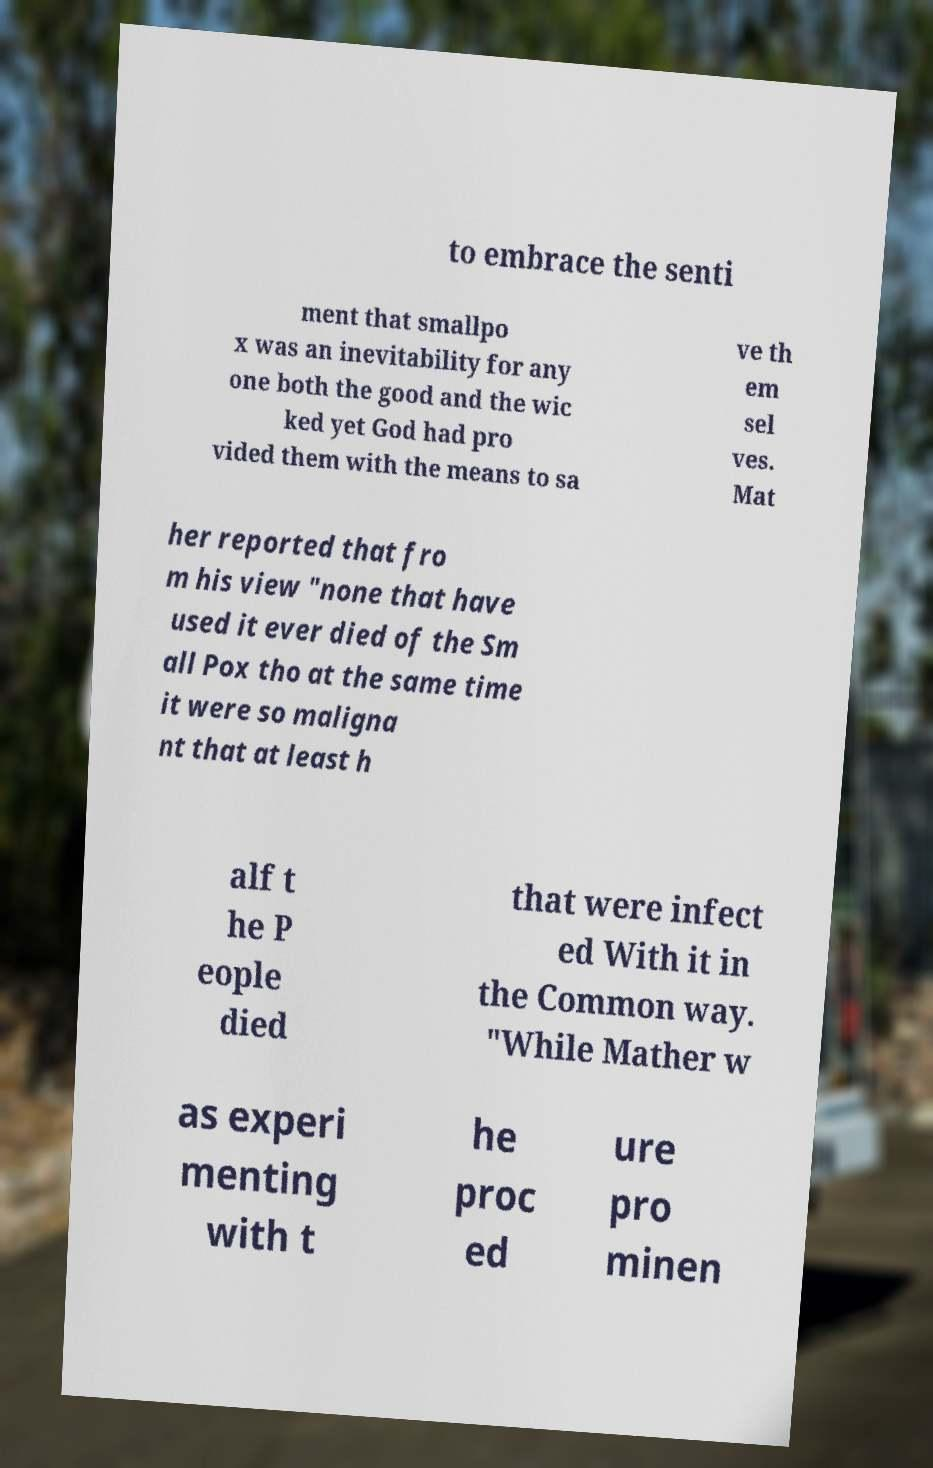Please read and relay the text visible in this image. What does it say? to embrace the senti ment that smallpo x was an inevitability for any one both the good and the wic ked yet God had pro vided them with the means to sa ve th em sel ves. Mat her reported that fro m his view "none that have used it ever died of the Sm all Pox tho at the same time it were so maligna nt that at least h alf t he P eople died that were infect ed With it in the Common way. "While Mather w as experi menting with t he proc ed ure pro minen 